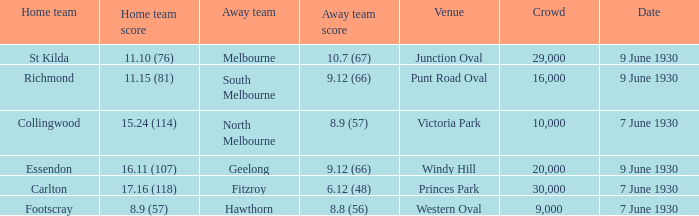What away team played Footscray? Hawthorn. 